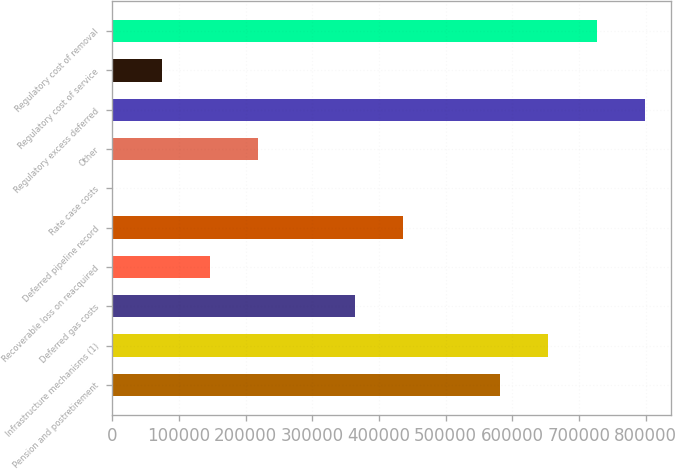Convert chart to OTSL. <chart><loc_0><loc_0><loc_500><loc_500><bar_chart><fcel>Pension and postretirement<fcel>Infrastructure mechanisms (1)<fcel>Deferred gas costs<fcel>Recoverable loss on reacquired<fcel>Deferred pipeline record<fcel>Rate case costs<fcel>Other<fcel>Regulatory excess deferred<fcel>Regulatory cost of service<fcel>Regulatory cost of removal<nl><fcel>581315<fcel>653811<fcel>363826<fcel>146338<fcel>436323<fcel>1346<fcel>218834<fcel>798803<fcel>73842.1<fcel>726307<nl></chart> 